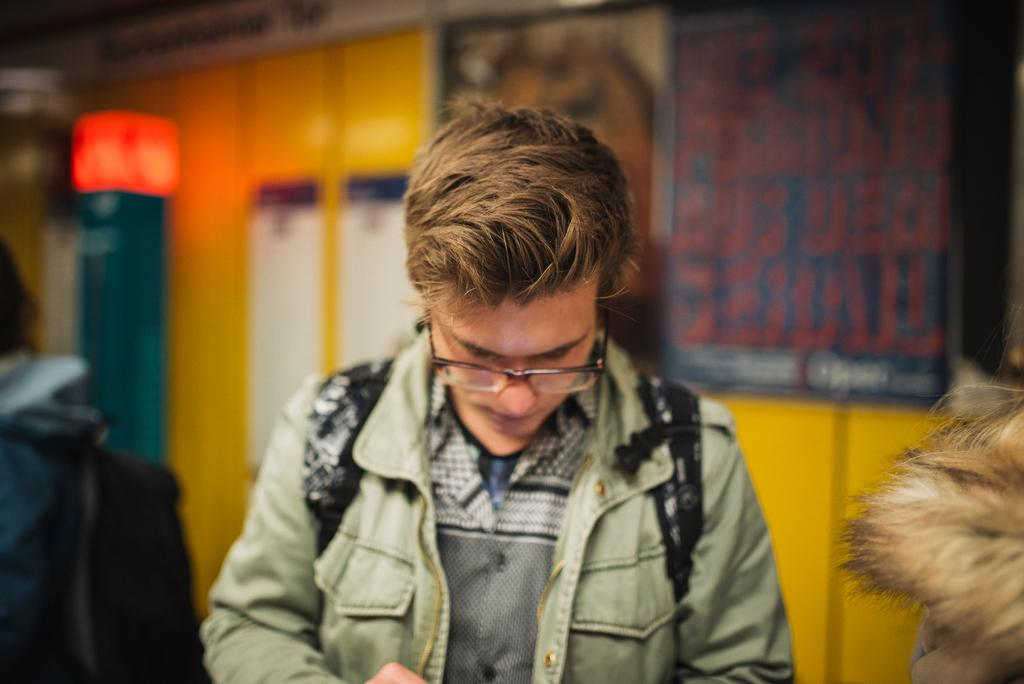What is the main subject of the image? There is a person in the image. Can you describe the background of the image? The background of the image is blurred. What can be observed about the person's attire? The person is wearing clothes. Are there any accessories visible on the person? Yes, the person is wearing spectacles. What type of yarn is the person using to cut with the scissors in the image? There are no scissors or yarn present in the image. Can you tell me the color of the crayon the person is holding in the image? There is no crayon present in the image. 